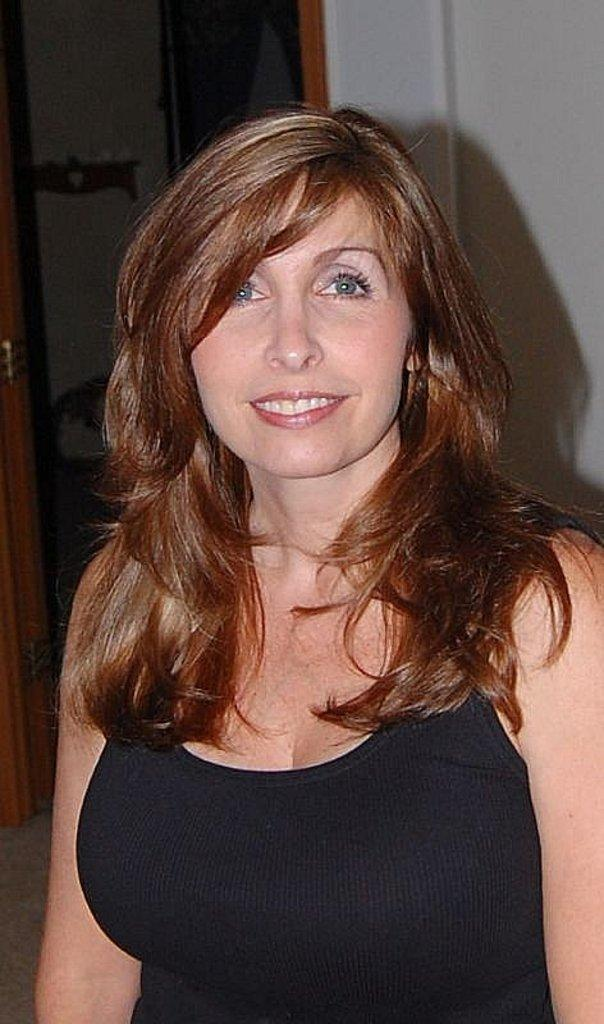Who or what is the main subject of the image? There is a person in the image. What is the person wearing? The person is wearing a black dress. What can be seen in the background of the image? The background of the image includes a wall. What color is the wall? The wall is white in color. How many eggs are visible on the wall in the image? There are no eggs visible on the wall in the image. What type of liquid can be seen flowing down the person's dress in the image? There is no liquid flowing down the person's dress in the image. 